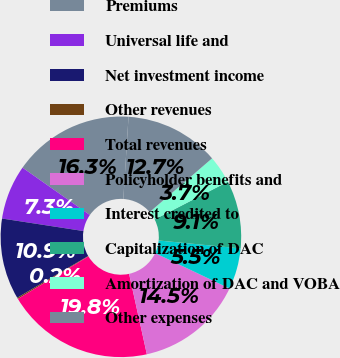<chart> <loc_0><loc_0><loc_500><loc_500><pie_chart><fcel>Premiums<fcel>Universal life and<fcel>Net investment income<fcel>Other revenues<fcel>Total revenues<fcel>Policyholder benefits and<fcel>Interest credited to<fcel>Capitalization of DAC<fcel>Amortization of DAC and VOBA<fcel>Other expenses<nl><fcel>16.26%<fcel>7.32%<fcel>10.89%<fcel>0.17%<fcel>19.83%<fcel>14.47%<fcel>5.53%<fcel>9.11%<fcel>3.74%<fcel>12.68%<nl></chart> 